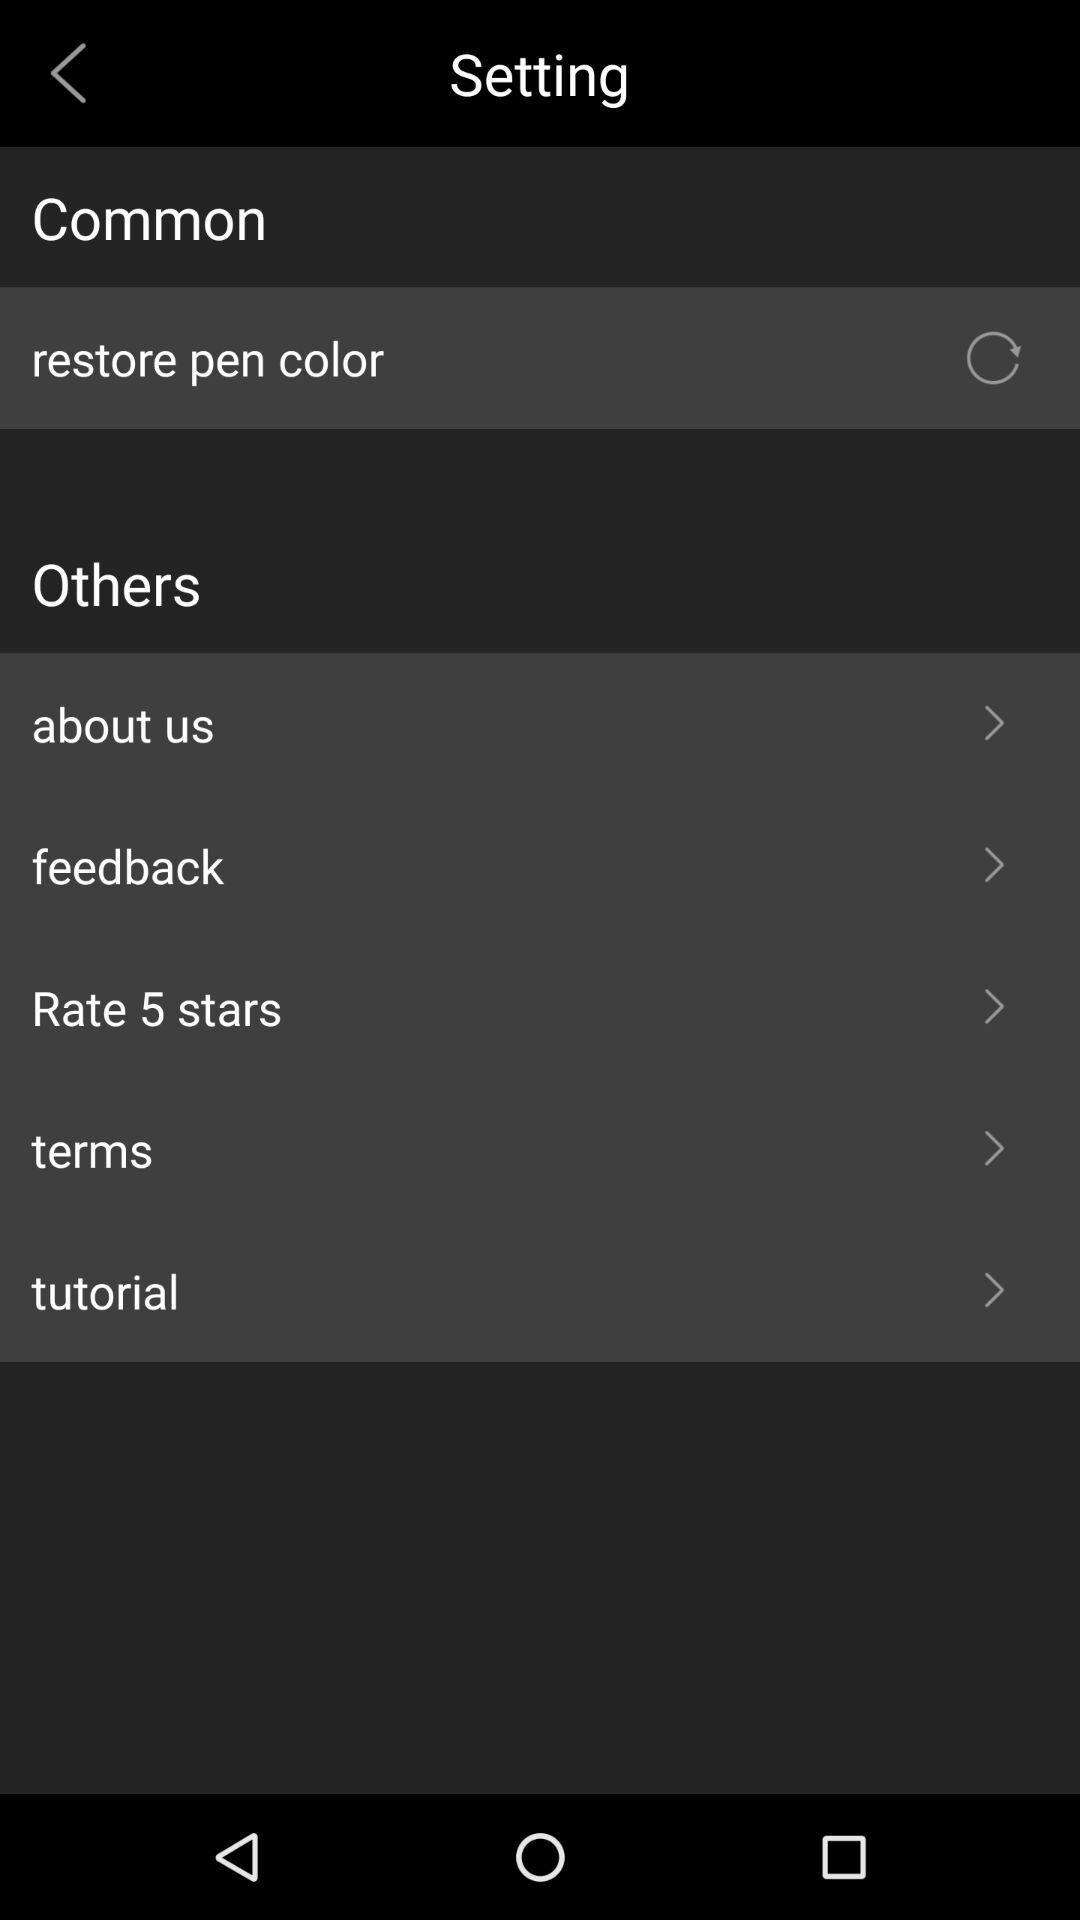How many items have a forward arrow?
Answer the question using a single word or phrase. 5 